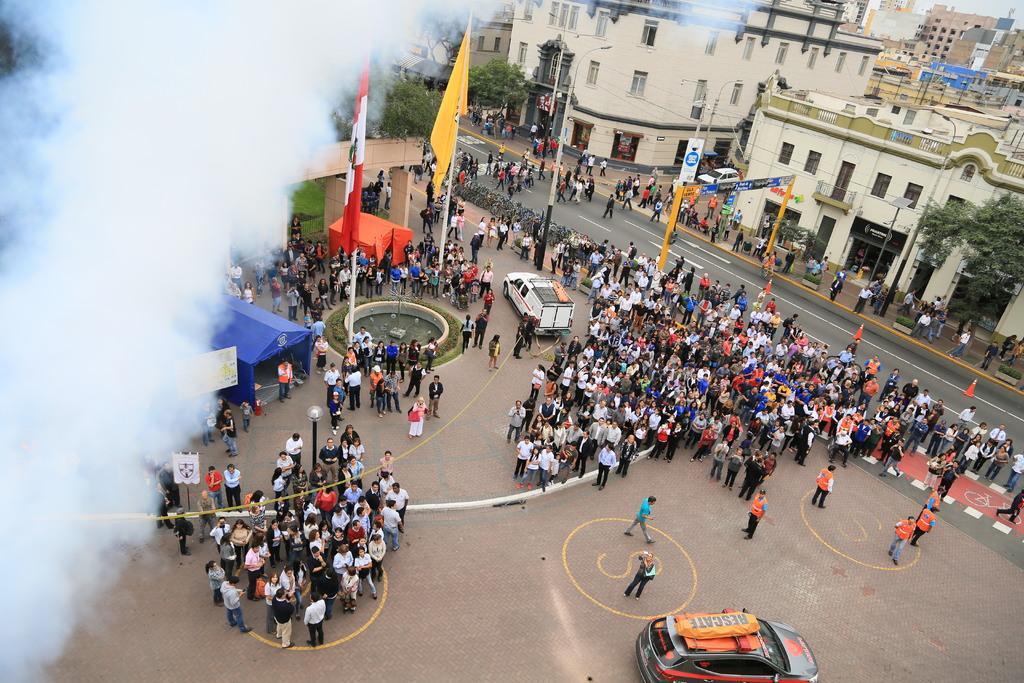Could you give a brief overview of what you see in this image? In this picture we can see a group of people standing on the ground, traffic cones on the road, vehicles, flags, tents, arch, trees, smoke and some objects and in the background we can see buildings with windows. 